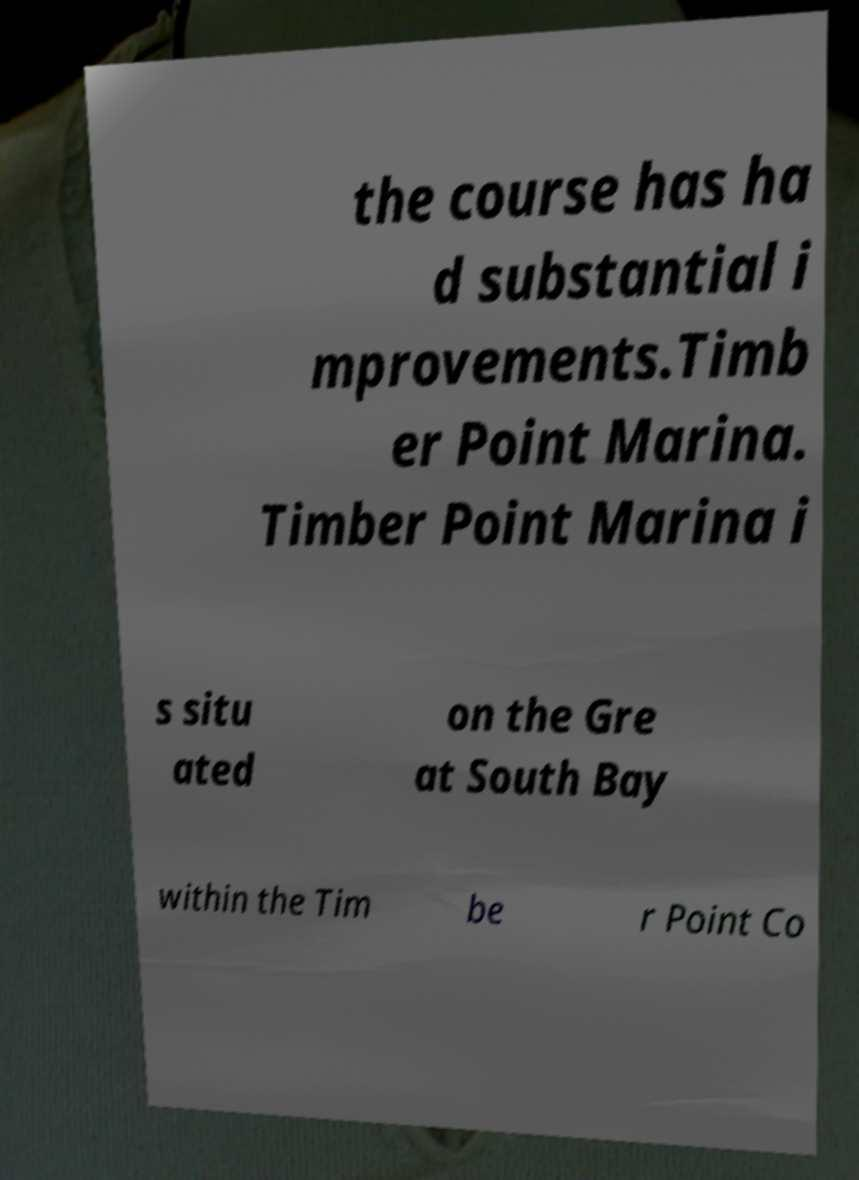There's text embedded in this image that I need extracted. Can you transcribe it verbatim? the course has ha d substantial i mprovements.Timb er Point Marina. Timber Point Marina i s situ ated on the Gre at South Bay within the Tim be r Point Co 